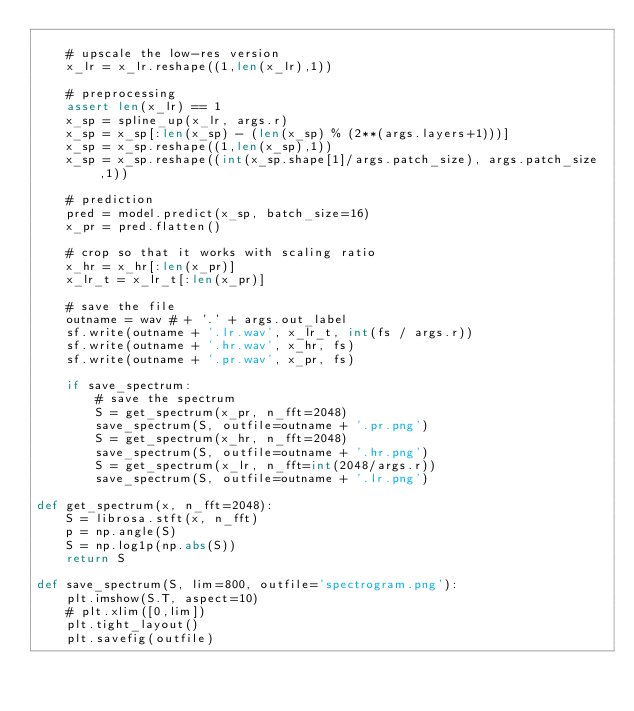<code> <loc_0><loc_0><loc_500><loc_500><_Python_>
    # upscale the low-res version
    x_lr = x_lr.reshape((1,len(x_lr),1))

    # preprocessing
    assert len(x_lr) == 1
    x_sp = spline_up(x_lr, args.r)
    x_sp = x_sp[:len(x_sp) - (len(x_sp) % (2**(args.layers+1)))]
    x_sp = x_sp.reshape((1,len(x_sp),1))
    x_sp = x_sp.reshape((int(x_sp.shape[1]/args.patch_size), args.patch_size,1))

    # prediction
    pred = model.predict(x_sp, batch_size=16)
    x_pr = pred.flatten()

    # crop so that it works with scaling ratio
    x_hr = x_hr[:len(x_pr)]
    x_lr_t = x_lr_t[:len(x_pr)]

    # save the file
    outname = wav # + '.' + args.out_label
    sf.write(outname + '.lr.wav', x_lr_t, int(fs / args.r))
    sf.write(outname + '.hr.wav', x_hr, fs)
    sf.write(outname + '.pr.wav', x_pr, fs)

    if save_spectrum:
        # save the spectrum
        S = get_spectrum(x_pr, n_fft=2048)
        save_spectrum(S, outfile=outname + '.pr.png')
        S = get_spectrum(x_hr, n_fft=2048)
        save_spectrum(S, outfile=outname + '.hr.png')
        S = get_spectrum(x_lr, n_fft=int(2048/args.r))
        save_spectrum(S, outfile=outname + '.lr.png')

def get_spectrum(x, n_fft=2048):
    S = librosa.stft(x, n_fft)
    p = np.angle(S)
    S = np.log1p(np.abs(S))
    return S

def save_spectrum(S, lim=800, outfile='spectrogram.png'):
    plt.imshow(S.T, aspect=10)
    # plt.xlim([0,lim])
    plt.tight_layout()
    plt.savefig(outfile)</code> 